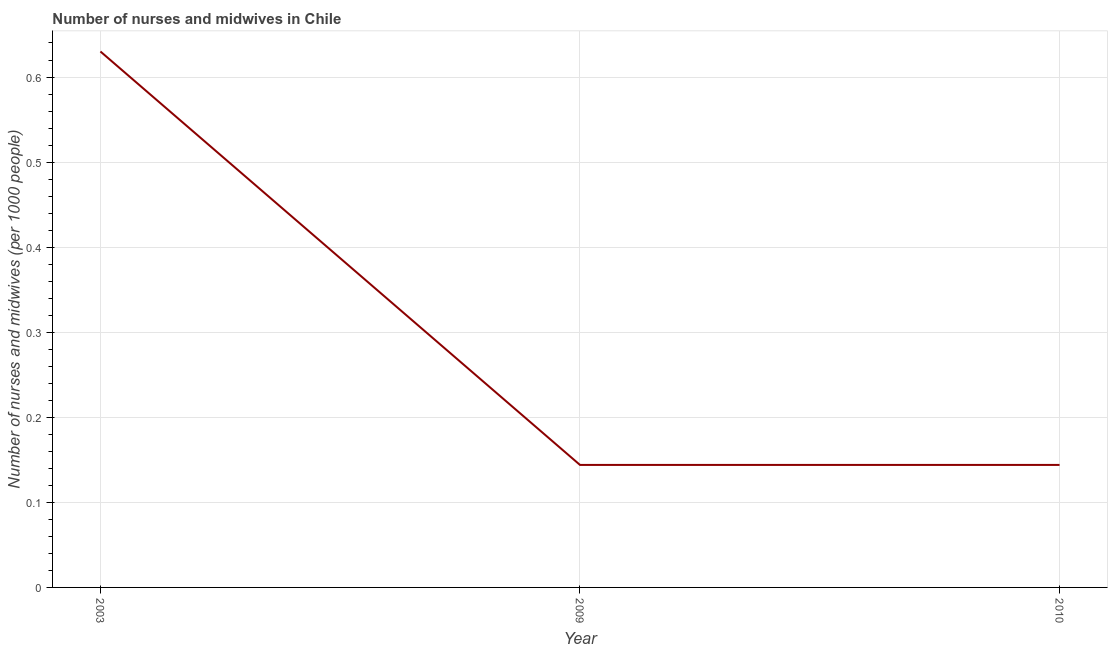What is the number of nurses and midwives in 2010?
Offer a very short reply. 0.14. Across all years, what is the maximum number of nurses and midwives?
Offer a terse response. 0.63. Across all years, what is the minimum number of nurses and midwives?
Your answer should be compact. 0.14. What is the sum of the number of nurses and midwives?
Your answer should be very brief. 0.92. What is the difference between the number of nurses and midwives in 2003 and 2009?
Your response must be concise. 0.49. What is the average number of nurses and midwives per year?
Your answer should be very brief. 0.31. What is the median number of nurses and midwives?
Make the answer very short. 0.14. In how many years, is the number of nurses and midwives greater than 0.46 ?
Make the answer very short. 1. Do a majority of the years between 2009 and 2003 (inclusive) have number of nurses and midwives greater than 0.14 ?
Make the answer very short. No. What is the ratio of the number of nurses and midwives in 2009 to that in 2010?
Your answer should be very brief. 1. Is the difference between the number of nurses and midwives in 2003 and 2009 greater than the difference between any two years?
Your answer should be very brief. Yes. What is the difference between the highest and the second highest number of nurses and midwives?
Ensure brevity in your answer.  0.49. What is the difference between the highest and the lowest number of nurses and midwives?
Keep it short and to the point. 0.49. In how many years, is the number of nurses and midwives greater than the average number of nurses and midwives taken over all years?
Your response must be concise. 1. How many lines are there?
Provide a short and direct response. 1. Are the values on the major ticks of Y-axis written in scientific E-notation?
Provide a succinct answer. No. Does the graph contain any zero values?
Make the answer very short. No. Does the graph contain grids?
Make the answer very short. Yes. What is the title of the graph?
Offer a terse response. Number of nurses and midwives in Chile. What is the label or title of the Y-axis?
Give a very brief answer. Number of nurses and midwives (per 1000 people). What is the Number of nurses and midwives (per 1000 people) of 2003?
Provide a short and direct response. 0.63. What is the Number of nurses and midwives (per 1000 people) in 2009?
Offer a very short reply. 0.14. What is the Number of nurses and midwives (per 1000 people) of 2010?
Your response must be concise. 0.14. What is the difference between the Number of nurses and midwives (per 1000 people) in 2003 and 2009?
Keep it short and to the point. 0.49. What is the difference between the Number of nurses and midwives (per 1000 people) in 2003 and 2010?
Keep it short and to the point. 0.49. What is the ratio of the Number of nurses and midwives (per 1000 people) in 2003 to that in 2009?
Provide a succinct answer. 4.38. What is the ratio of the Number of nurses and midwives (per 1000 people) in 2003 to that in 2010?
Provide a succinct answer. 4.38. 